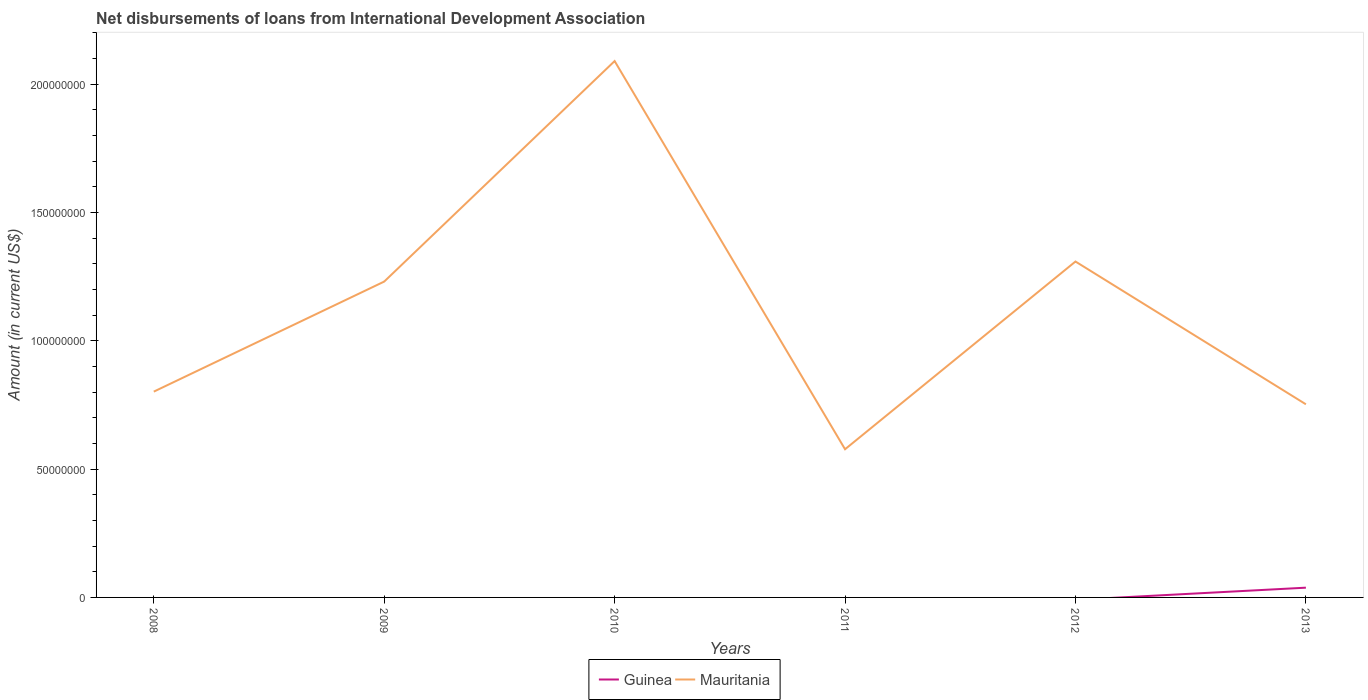Does the line corresponding to Guinea intersect with the line corresponding to Mauritania?
Your response must be concise. No. Across all years, what is the maximum amount of loans disbursed in Mauritania?
Ensure brevity in your answer.  5.77e+07. What is the total amount of loans disbursed in Mauritania in the graph?
Give a very brief answer. 1.51e+08. What is the difference between the highest and the second highest amount of loans disbursed in Guinea?
Keep it short and to the point. 3.80e+06. Is the amount of loans disbursed in Mauritania strictly greater than the amount of loans disbursed in Guinea over the years?
Give a very brief answer. No. How many lines are there?
Ensure brevity in your answer.  2. What is the difference between two consecutive major ticks on the Y-axis?
Offer a terse response. 5.00e+07. Does the graph contain grids?
Your response must be concise. No. How are the legend labels stacked?
Provide a short and direct response. Horizontal. What is the title of the graph?
Provide a short and direct response. Net disbursements of loans from International Development Association. What is the label or title of the Y-axis?
Your answer should be compact. Amount (in current US$). What is the Amount (in current US$) of Mauritania in 2008?
Keep it short and to the point. 8.02e+07. What is the Amount (in current US$) of Guinea in 2009?
Your response must be concise. 0. What is the Amount (in current US$) of Mauritania in 2009?
Make the answer very short. 1.23e+08. What is the Amount (in current US$) in Guinea in 2010?
Provide a short and direct response. 0. What is the Amount (in current US$) in Mauritania in 2010?
Your answer should be compact. 2.09e+08. What is the Amount (in current US$) in Guinea in 2011?
Offer a very short reply. 0. What is the Amount (in current US$) in Mauritania in 2011?
Your answer should be very brief. 5.77e+07. What is the Amount (in current US$) in Guinea in 2012?
Keep it short and to the point. 0. What is the Amount (in current US$) of Mauritania in 2012?
Your response must be concise. 1.31e+08. What is the Amount (in current US$) of Guinea in 2013?
Make the answer very short. 3.80e+06. What is the Amount (in current US$) of Mauritania in 2013?
Ensure brevity in your answer.  7.52e+07. Across all years, what is the maximum Amount (in current US$) of Guinea?
Provide a succinct answer. 3.80e+06. Across all years, what is the maximum Amount (in current US$) of Mauritania?
Keep it short and to the point. 2.09e+08. Across all years, what is the minimum Amount (in current US$) in Guinea?
Your answer should be very brief. 0. Across all years, what is the minimum Amount (in current US$) in Mauritania?
Make the answer very short. 5.77e+07. What is the total Amount (in current US$) of Guinea in the graph?
Offer a very short reply. 3.80e+06. What is the total Amount (in current US$) of Mauritania in the graph?
Your response must be concise. 6.76e+08. What is the difference between the Amount (in current US$) in Mauritania in 2008 and that in 2009?
Provide a short and direct response. -4.29e+07. What is the difference between the Amount (in current US$) in Mauritania in 2008 and that in 2010?
Give a very brief answer. -1.29e+08. What is the difference between the Amount (in current US$) in Mauritania in 2008 and that in 2011?
Provide a succinct answer. 2.24e+07. What is the difference between the Amount (in current US$) in Mauritania in 2008 and that in 2012?
Ensure brevity in your answer.  -5.07e+07. What is the difference between the Amount (in current US$) in Mauritania in 2008 and that in 2013?
Keep it short and to the point. 4.93e+06. What is the difference between the Amount (in current US$) of Mauritania in 2009 and that in 2010?
Ensure brevity in your answer.  -8.59e+07. What is the difference between the Amount (in current US$) in Mauritania in 2009 and that in 2011?
Provide a succinct answer. 6.53e+07. What is the difference between the Amount (in current US$) of Mauritania in 2009 and that in 2012?
Provide a succinct answer. -7.81e+06. What is the difference between the Amount (in current US$) of Mauritania in 2009 and that in 2013?
Keep it short and to the point. 4.78e+07. What is the difference between the Amount (in current US$) of Mauritania in 2010 and that in 2011?
Keep it short and to the point. 1.51e+08. What is the difference between the Amount (in current US$) in Mauritania in 2010 and that in 2012?
Your answer should be very brief. 7.81e+07. What is the difference between the Amount (in current US$) of Mauritania in 2010 and that in 2013?
Your response must be concise. 1.34e+08. What is the difference between the Amount (in current US$) of Mauritania in 2011 and that in 2012?
Provide a succinct answer. -7.31e+07. What is the difference between the Amount (in current US$) of Mauritania in 2011 and that in 2013?
Keep it short and to the point. -1.75e+07. What is the difference between the Amount (in current US$) in Mauritania in 2012 and that in 2013?
Make the answer very short. 5.56e+07. What is the average Amount (in current US$) in Guinea per year?
Offer a very short reply. 6.33e+05. What is the average Amount (in current US$) in Mauritania per year?
Offer a very short reply. 1.13e+08. In the year 2013, what is the difference between the Amount (in current US$) of Guinea and Amount (in current US$) of Mauritania?
Offer a terse response. -7.14e+07. What is the ratio of the Amount (in current US$) of Mauritania in 2008 to that in 2009?
Provide a succinct answer. 0.65. What is the ratio of the Amount (in current US$) in Mauritania in 2008 to that in 2010?
Offer a very short reply. 0.38. What is the ratio of the Amount (in current US$) in Mauritania in 2008 to that in 2011?
Offer a terse response. 1.39. What is the ratio of the Amount (in current US$) in Mauritania in 2008 to that in 2012?
Offer a terse response. 0.61. What is the ratio of the Amount (in current US$) in Mauritania in 2008 to that in 2013?
Give a very brief answer. 1.07. What is the ratio of the Amount (in current US$) of Mauritania in 2009 to that in 2010?
Keep it short and to the point. 0.59. What is the ratio of the Amount (in current US$) of Mauritania in 2009 to that in 2011?
Your answer should be very brief. 2.13. What is the ratio of the Amount (in current US$) of Mauritania in 2009 to that in 2012?
Offer a terse response. 0.94. What is the ratio of the Amount (in current US$) of Mauritania in 2009 to that in 2013?
Provide a succinct answer. 1.64. What is the ratio of the Amount (in current US$) in Mauritania in 2010 to that in 2011?
Provide a succinct answer. 3.62. What is the ratio of the Amount (in current US$) in Mauritania in 2010 to that in 2012?
Provide a short and direct response. 1.6. What is the ratio of the Amount (in current US$) of Mauritania in 2010 to that in 2013?
Give a very brief answer. 2.78. What is the ratio of the Amount (in current US$) in Mauritania in 2011 to that in 2012?
Offer a terse response. 0.44. What is the ratio of the Amount (in current US$) in Mauritania in 2011 to that in 2013?
Provide a short and direct response. 0.77. What is the ratio of the Amount (in current US$) of Mauritania in 2012 to that in 2013?
Provide a short and direct response. 1.74. What is the difference between the highest and the second highest Amount (in current US$) of Mauritania?
Provide a succinct answer. 7.81e+07. What is the difference between the highest and the lowest Amount (in current US$) in Guinea?
Keep it short and to the point. 3.80e+06. What is the difference between the highest and the lowest Amount (in current US$) in Mauritania?
Your answer should be very brief. 1.51e+08. 